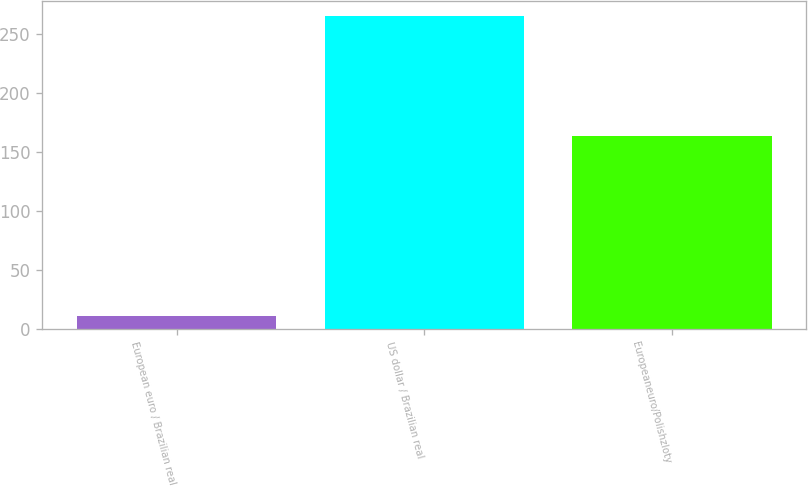Convert chart. <chart><loc_0><loc_0><loc_500><loc_500><bar_chart><fcel>European euro / Brazilian real<fcel>US dollar / Brazilian real<fcel>Europeaneuro/Polishzloty<nl><fcel>11<fcel>265<fcel>164<nl></chart> 